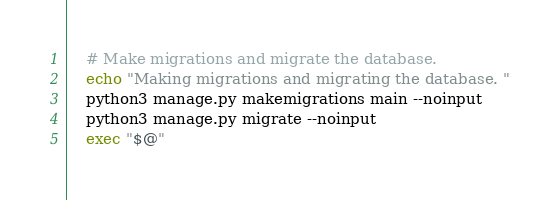<code> <loc_0><loc_0><loc_500><loc_500><_Bash_>    # Make migrations and migrate the database.
    echo "Making migrations and migrating the database. "
    python3 manage.py makemigrations main --noinput 
    python3 manage.py migrate --noinput 
    exec "$@"
</code> 